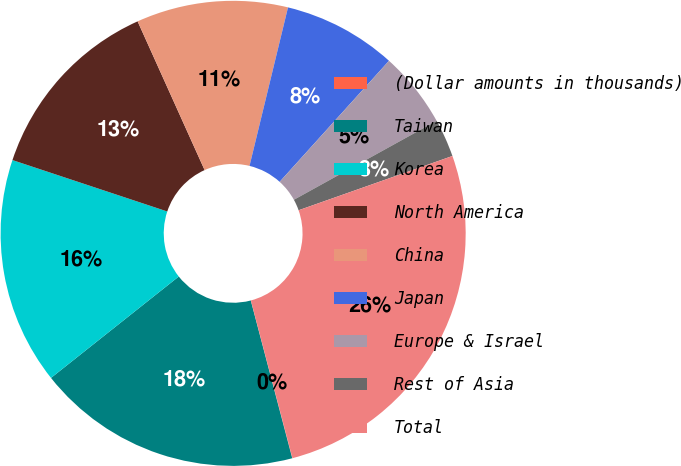<chart> <loc_0><loc_0><loc_500><loc_500><pie_chart><fcel>(Dollar amounts in thousands)<fcel>Taiwan<fcel>Korea<fcel>North America<fcel>China<fcel>Japan<fcel>Europe & Israel<fcel>Rest of Asia<fcel>Total<nl><fcel>0.02%<fcel>18.41%<fcel>15.78%<fcel>13.16%<fcel>10.53%<fcel>7.9%<fcel>5.27%<fcel>2.64%<fcel>26.29%<nl></chart> 